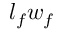<formula> <loc_0><loc_0><loc_500><loc_500>{ l _ { f } w _ { f } }</formula> 